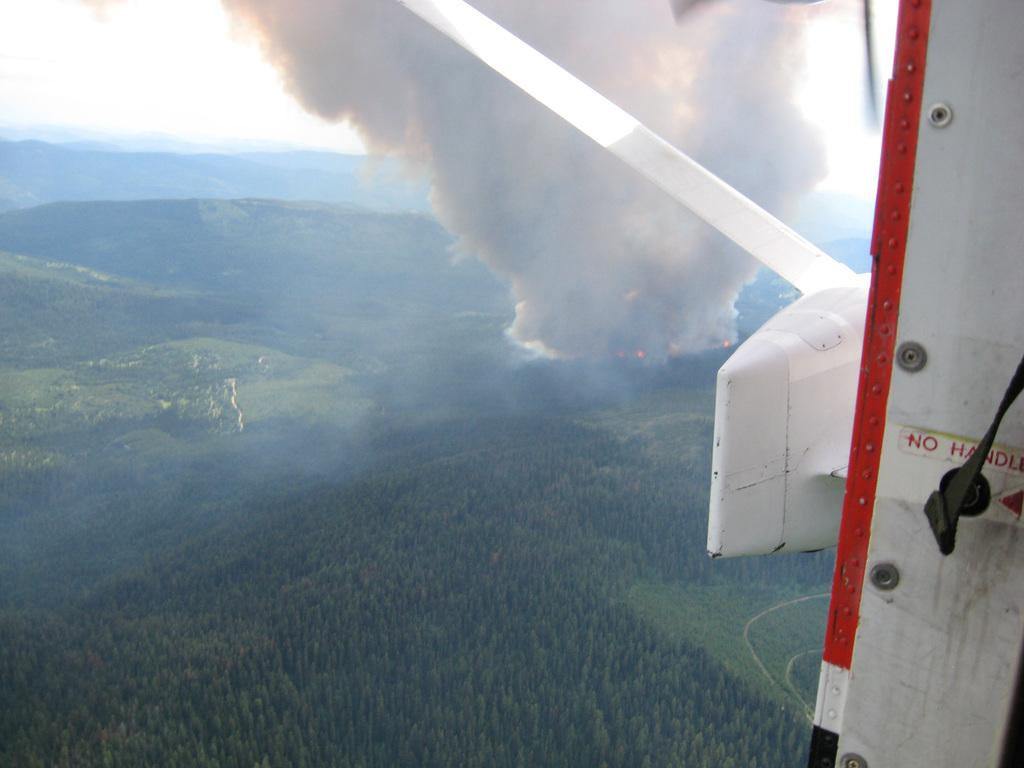What is the perspective of the image? The image is clicked from an aircraft. What type of vegetation can be seen in the image? There are trees, plants, and green grass visible in the image. Is there any visible smoke in the image? Yes, there is smoke visible in the image. What letter is being used to create the shade in the image? There is no shade or letter present in the image. What type of produce can be seen growing in the image? There is no produce visible in the image. 